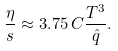<formula> <loc_0><loc_0><loc_500><loc_500>\frac { \eta } { s } \approx 3 . 7 5 \, C \frac { T ^ { 3 } } { \hat { q } } .</formula> 